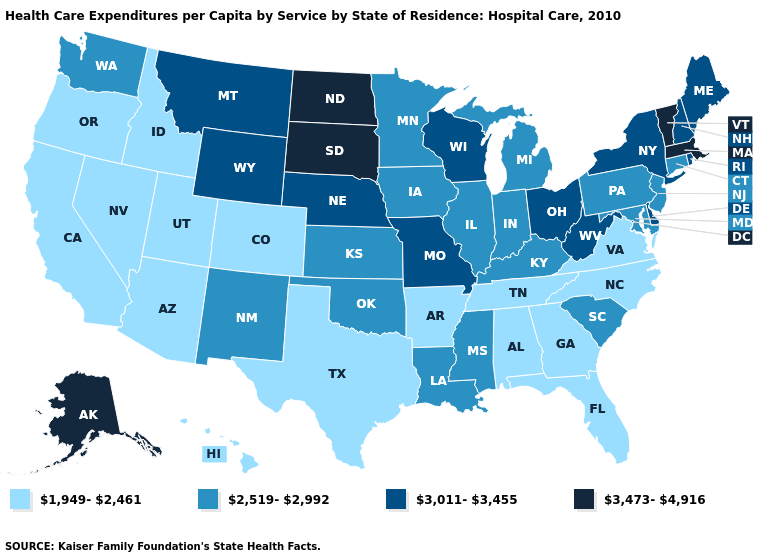What is the highest value in the West ?
Be succinct. 3,473-4,916. Name the states that have a value in the range 2,519-2,992?
Short answer required. Connecticut, Illinois, Indiana, Iowa, Kansas, Kentucky, Louisiana, Maryland, Michigan, Minnesota, Mississippi, New Jersey, New Mexico, Oklahoma, Pennsylvania, South Carolina, Washington. Does Maryland have a lower value than Delaware?
Write a very short answer. Yes. What is the value of Washington?
Be succinct. 2,519-2,992. Which states hav the highest value in the MidWest?
Quick response, please. North Dakota, South Dakota. What is the lowest value in the West?
Write a very short answer. 1,949-2,461. Among the states that border North Carolina , does Tennessee have the highest value?
Short answer required. No. Which states have the highest value in the USA?
Write a very short answer. Alaska, Massachusetts, North Dakota, South Dakota, Vermont. Name the states that have a value in the range 3,473-4,916?
Be succinct. Alaska, Massachusetts, North Dakota, South Dakota, Vermont. Name the states that have a value in the range 3,011-3,455?
Write a very short answer. Delaware, Maine, Missouri, Montana, Nebraska, New Hampshire, New York, Ohio, Rhode Island, West Virginia, Wisconsin, Wyoming. Which states hav the highest value in the MidWest?
Write a very short answer. North Dakota, South Dakota. Among the states that border Indiana , does Ohio have the highest value?
Answer briefly. Yes. What is the value of Wisconsin?
Keep it brief. 3,011-3,455. Does Montana have a higher value than Vermont?
Concise answer only. No. Name the states that have a value in the range 3,011-3,455?
Quick response, please. Delaware, Maine, Missouri, Montana, Nebraska, New Hampshire, New York, Ohio, Rhode Island, West Virginia, Wisconsin, Wyoming. 